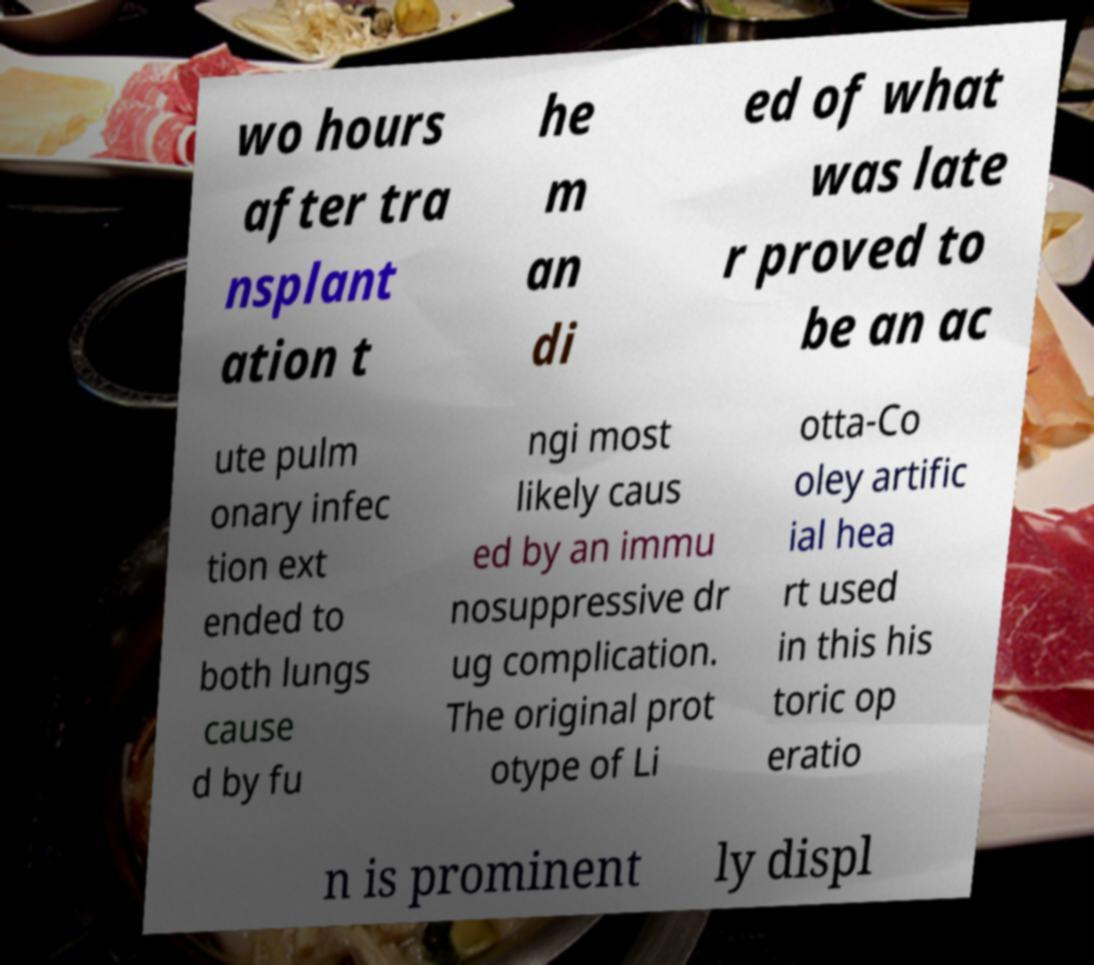I need the written content from this picture converted into text. Can you do that? wo hours after tra nsplant ation t he m an di ed of what was late r proved to be an ac ute pulm onary infec tion ext ended to both lungs cause d by fu ngi most likely caus ed by an immu nosuppressive dr ug complication. The original prot otype of Li otta-Co oley artific ial hea rt used in this his toric op eratio n is prominent ly displ 